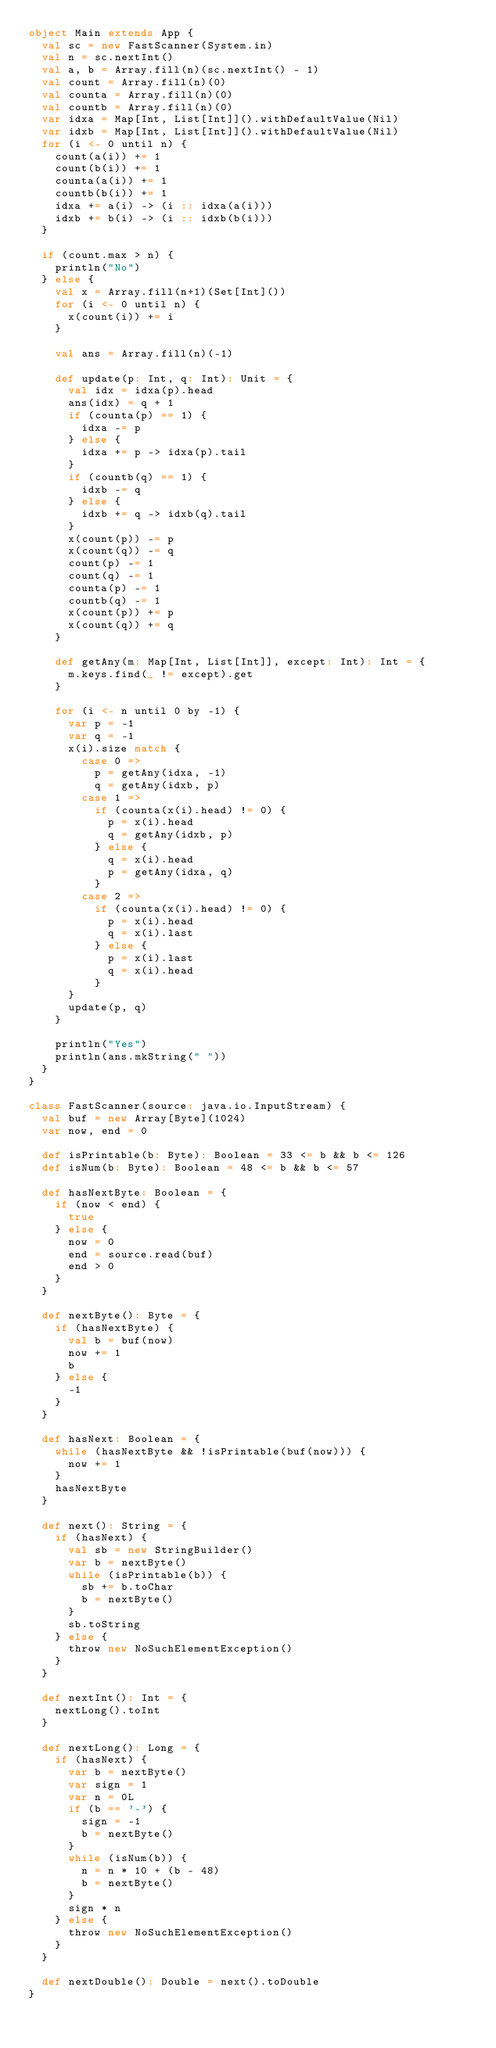Convert code to text. <code><loc_0><loc_0><loc_500><loc_500><_Scala_>object Main extends App {
  val sc = new FastScanner(System.in)
  val n = sc.nextInt()
  val a, b = Array.fill(n)(sc.nextInt() - 1)
  val count = Array.fill(n)(0)
  val counta = Array.fill(n)(0)
  val countb = Array.fill(n)(0)
  var idxa = Map[Int, List[Int]]().withDefaultValue(Nil)
  var idxb = Map[Int, List[Int]]().withDefaultValue(Nil)
  for (i <- 0 until n) {
    count(a(i)) += 1
    count(b(i)) += 1
    counta(a(i)) += 1
    countb(b(i)) += 1
    idxa += a(i) -> (i :: idxa(a(i)))
    idxb += b(i) -> (i :: idxb(b(i)))
  }

  if (count.max > n) {
    println("No")
  } else {
    val x = Array.fill(n+1)(Set[Int]())
    for (i <- 0 until n) {
      x(count(i)) += i
    }

    val ans = Array.fill(n)(-1)

    def update(p: Int, q: Int): Unit = {
      val idx = idxa(p).head
      ans(idx) = q + 1
      if (counta(p) == 1) {
        idxa -= p
      } else {
        idxa += p -> idxa(p).tail
      }
      if (countb(q) == 1) {
        idxb -= q
      } else {
        idxb += q -> idxb(q).tail
      }
      x(count(p)) -= p
      x(count(q)) -= q
      count(p) -= 1
      count(q) -= 1
      counta(p) -= 1
      countb(q) -= 1
      x(count(p)) += p
      x(count(q)) += q
    }

    def getAny(m: Map[Int, List[Int]], except: Int): Int = {
      m.keys.find(_ != except).get
    }

    for (i <- n until 0 by -1) {
      var p = -1
      var q = -1
      x(i).size match {
        case 0 =>
          p = getAny(idxa, -1)
          q = getAny(idxb, p)
        case 1 =>
          if (counta(x(i).head) != 0) {
            p = x(i).head
            q = getAny(idxb, p)
          } else {
            q = x(i).head
            p = getAny(idxa, q)
          }
        case 2 =>
          if (counta(x(i).head) != 0) {
            p = x(i).head
            q = x(i).last
          } else {
            p = x(i).last
            q = x(i).head
          }
      }
      update(p, q)
    }

    println("Yes")
    println(ans.mkString(" "))
  }
}

class FastScanner(source: java.io.InputStream) {
  val buf = new Array[Byte](1024)
  var now, end = 0

  def isPrintable(b: Byte): Boolean = 33 <= b && b <= 126
  def isNum(b: Byte): Boolean = 48 <= b && b <= 57

  def hasNextByte: Boolean = {
    if (now < end) {
      true
    } else {
      now = 0
      end = source.read(buf)
      end > 0
    }
  }

  def nextByte(): Byte = {
    if (hasNextByte) {
      val b = buf(now)
      now += 1
      b
    } else {
      -1
    }
  }

  def hasNext: Boolean = {
    while (hasNextByte && !isPrintable(buf(now))) {
      now += 1
    }
    hasNextByte
  }

  def next(): String = {
    if (hasNext) {
      val sb = new StringBuilder()
      var b = nextByte()
      while (isPrintable(b)) {
        sb += b.toChar
        b = nextByte()
      }
      sb.toString
    } else {
      throw new NoSuchElementException()
    }
  }

  def nextInt(): Int = {
    nextLong().toInt
  }

  def nextLong(): Long = {
    if (hasNext) {
      var b = nextByte()
      var sign = 1
      var n = 0L
      if (b == '-') {
        sign = -1
        b = nextByte()
      }
      while (isNum(b)) {
        n = n * 10 + (b - 48)
        b = nextByte()
      }
      sign * n
    } else {
      throw new NoSuchElementException()
    }
  }

  def nextDouble(): Double = next().toDouble
}
</code> 